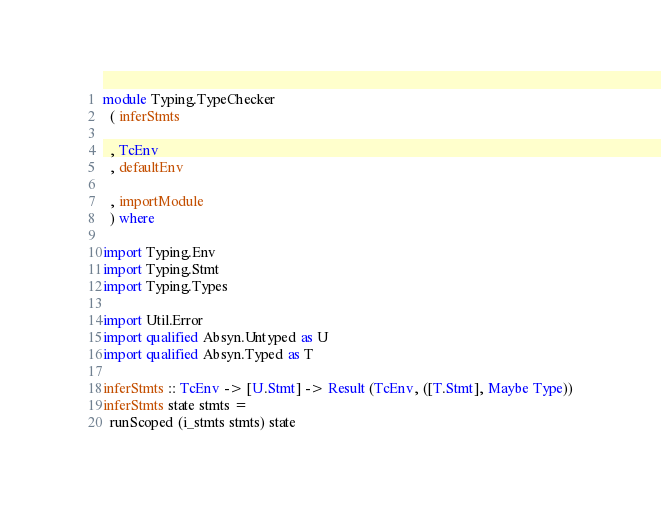Convert code to text. <code><loc_0><loc_0><loc_500><loc_500><_Haskell_>module Typing.TypeChecker
  ( inferStmts

  , TcEnv
  , defaultEnv

  , importModule
  ) where

import Typing.Env
import Typing.Stmt
import Typing.Types

import Util.Error
import qualified Absyn.Untyped as U
import qualified Absyn.Typed as T

inferStmts :: TcEnv -> [U.Stmt] -> Result (TcEnv, ([T.Stmt], Maybe Type))
inferStmts state stmts =
  runScoped (i_stmts stmts) state
</code> 